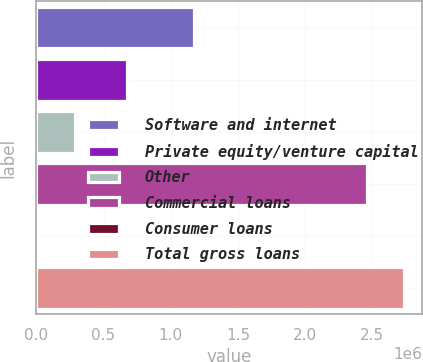<chart> <loc_0><loc_0><loc_500><loc_500><bar_chart><fcel>Software and internet<fcel>Private equity/venture capital<fcel>Other<fcel>Commercial loans<fcel>Consumer loans<fcel>Total gross loans<nl><fcel>1.17441e+06<fcel>677568<fcel>288047<fcel>2.45876e+06<fcel>16418<fcel>2.73271e+06<nl></chart> 